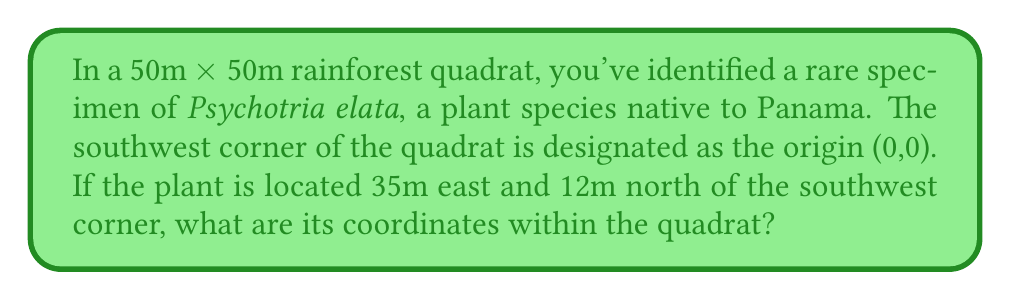Could you help me with this problem? To solve this problem, we need to understand that the quadrat represents a coordinate system where:
1. The origin (0,0) is at the southwest corner
2. The x-axis runs from west to east
3. The y-axis runs from south to north

Given information:
- The quadrat is 50m x 50m
- The plant is 35m east of the origin
- The plant is 12m north of the origin

In this coordinate system:
- Moving east increases the x-coordinate
- Moving north increases the y-coordinate

Therefore:
- The x-coordinate of the plant is 35
- The y-coordinate of the plant is 12

The coordinates are typically written as an ordered pair $(x,y)$.
Answer: The coordinates of the Psychotria elata specimen in the quadrat are $(35,12)$. 